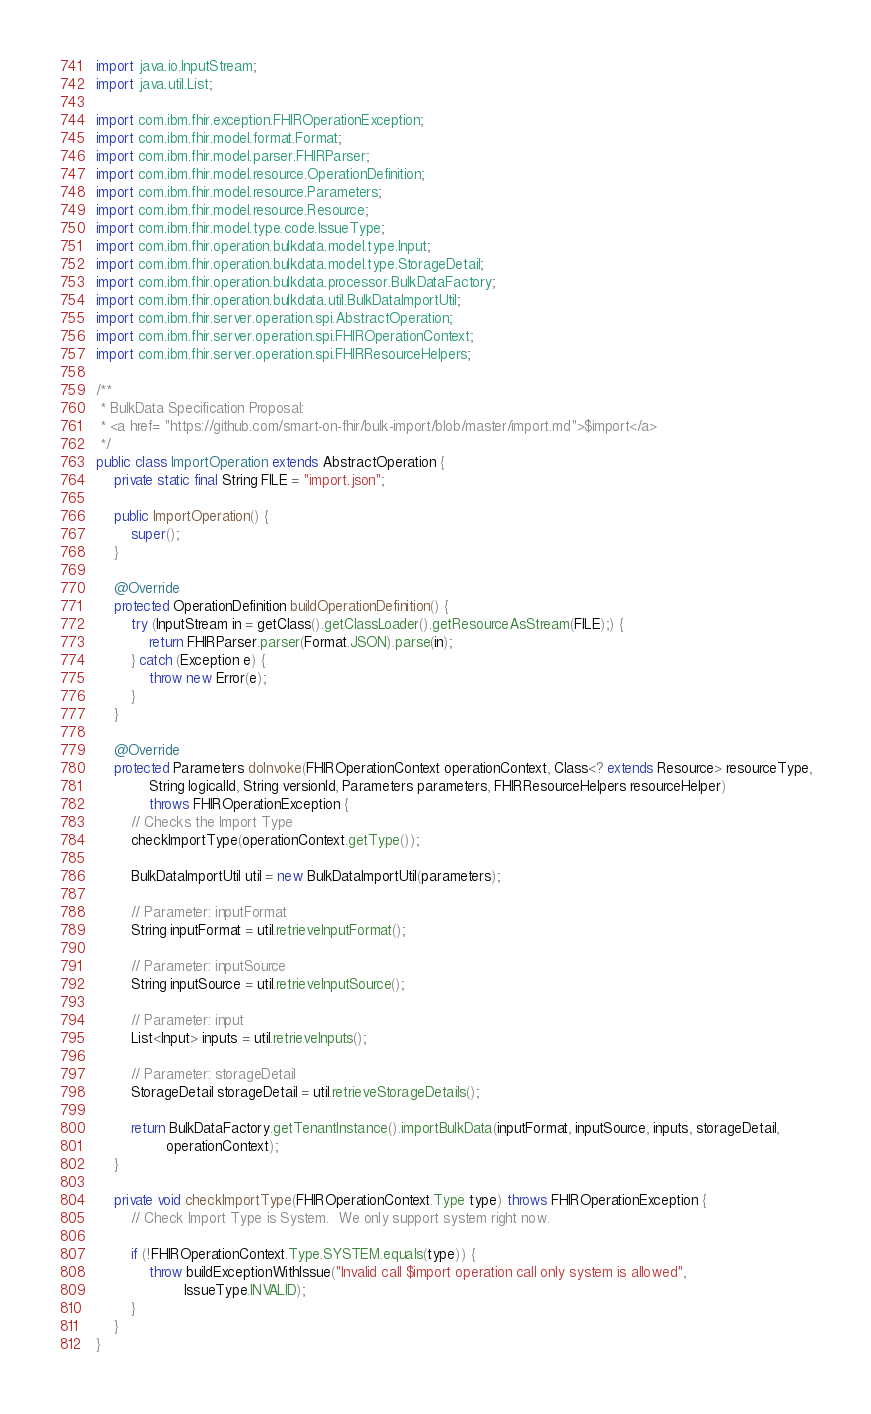Convert code to text. <code><loc_0><loc_0><loc_500><loc_500><_Java_>import java.io.InputStream;
import java.util.List;

import com.ibm.fhir.exception.FHIROperationException;
import com.ibm.fhir.model.format.Format;
import com.ibm.fhir.model.parser.FHIRParser;
import com.ibm.fhir.model.resource.OperationDefinition;
import com.ibm.fhir.model.resource.Parameters;
import com.ibm.fhir.model.resource.Resource;
import com.ibm.fhir.model.type.code.IssueType;
import com.ibm.fhir.operation.bulkdata.model.type.Input;
import com.ibm.fhir.operation.bulkdata.model.type.StorageDetail;
import com.ibm.fhir.operation.bulkdata.processor.BulkDataFactory;
import com.ibm.fhir.operation.bulkdata.util.BulkDataImportUtil;
import com.ibm.fhir.server.operation.spi.AbstractOperation;
import com.ibm.fhir.server.operation.spi.FHIROperationContext;
import com.ibm.fhir.server.operation.spi.FHIRResourceHelpers;

/**
 * BulkData Specification Proposal:
 * <a href= "https://github.com/smart-on-fhir/bulk-import/blob/master/import.md">$import</a>
 */
public class ImportOperation extends AbstractOperation {
    private static final String FILE = "import.json";

    public ImportOperation() {
        super();
    }

    @Override
    protected OperationDefinition buildOperationDefinition() {
        try (InputStream in = getClass().getClassLoader().getResourceAsStream(FILE);) {
            return FHIRParser.parser(Format.JSON).parse(in);
        } catch (Exception e) {
            throw new Error(e);
        }
    }

    @Override
    protected Parameters doInvoke(FHIROperationContext operationContext, Class<? extends Resource> resourceType,
            String logicalId, String versionId, Parameters parameters, FHIRResourceHelpers resourceHelper)
            throws FHIROperationException {
        // Checks the Import Type
        checkImportType(operationContext.getType());

        BulkDataImportUtil util = new BulkDataImportUtil(parameters);

        // Parameter: inputFormat
        String inputFormat = util.retrieveInputFormat();

        // Parameter: inputSource
        String inputSource = util.retrieveInputSource();

        // Parameter: input
        List<Input> inputs = util.retrieveInputs();

        // Parameter: storageDetail
        StorageDetail storageDetail = util.retrieveStorageDetails();

        return BulkDataFactory.getTenantInstance().importBulkData(inputFormat, inputSource, inputs, storageDetail,
                operationContext);
    }

    private void checkImportType(FHIROperationContext.Type type) throws FHIROperationException {
        // Check Import Type is System.  We only support system right now.

        if (!FHIROperationContext.Type.SYSTEM.equals(type)) {
            throw buildExceptionWithIssue("Invalid call $import operation call only system is allowed",
                    IssueType.INVALID);
        }
    }
}</code> 